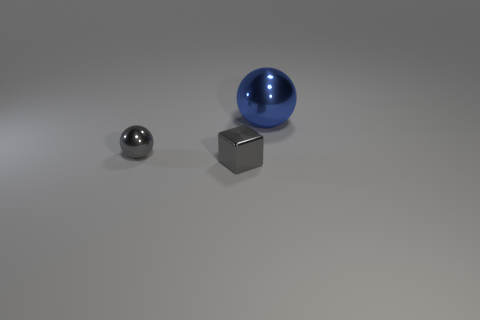Add 3 small gray things. How many objects exist? 6 Subtract all gray balls. How many balls are left? 1 Subtract all cubes. How many objects are left? 2 Subtract 1 balls. How many balls are left? 1 Subtract all red blocks. How many green balls are left? 0 Subtract all purple metal objects. Subtract all large metal things. How many objects are left? 2 Add 3 big blue objects. How many big blue objects are left? 4 Add 1 small gray rubber balls. How many small gray rubber balls exist? 1 Subtract 0 gray cylinders. How many objects are left? 3 Subtract all blue blocks. Subtract all green cylinders. How many blocks are left? 1 